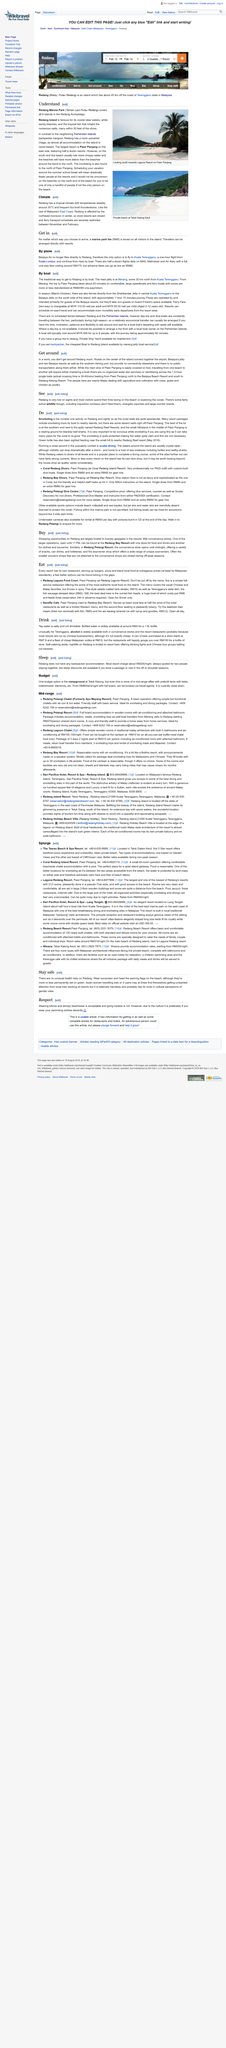Point out several critical features in this image. The state dish of Terengganu is fish sausage keropok lekor, which is known for its delectable taste and popularity among the locals and tourists. Redang Marine Park comprises of nine islands, and Redang Island is not the only island in the park. The main street of Pasir Panjang can easily be covered on foot, as it is the primary area where most of the stalls and shops are located. The tap water is not drinkable as it is salty and not suitable for human consumption. The jetty at Merang is located approximately 30 kilometers from Kuala Terengganu. 